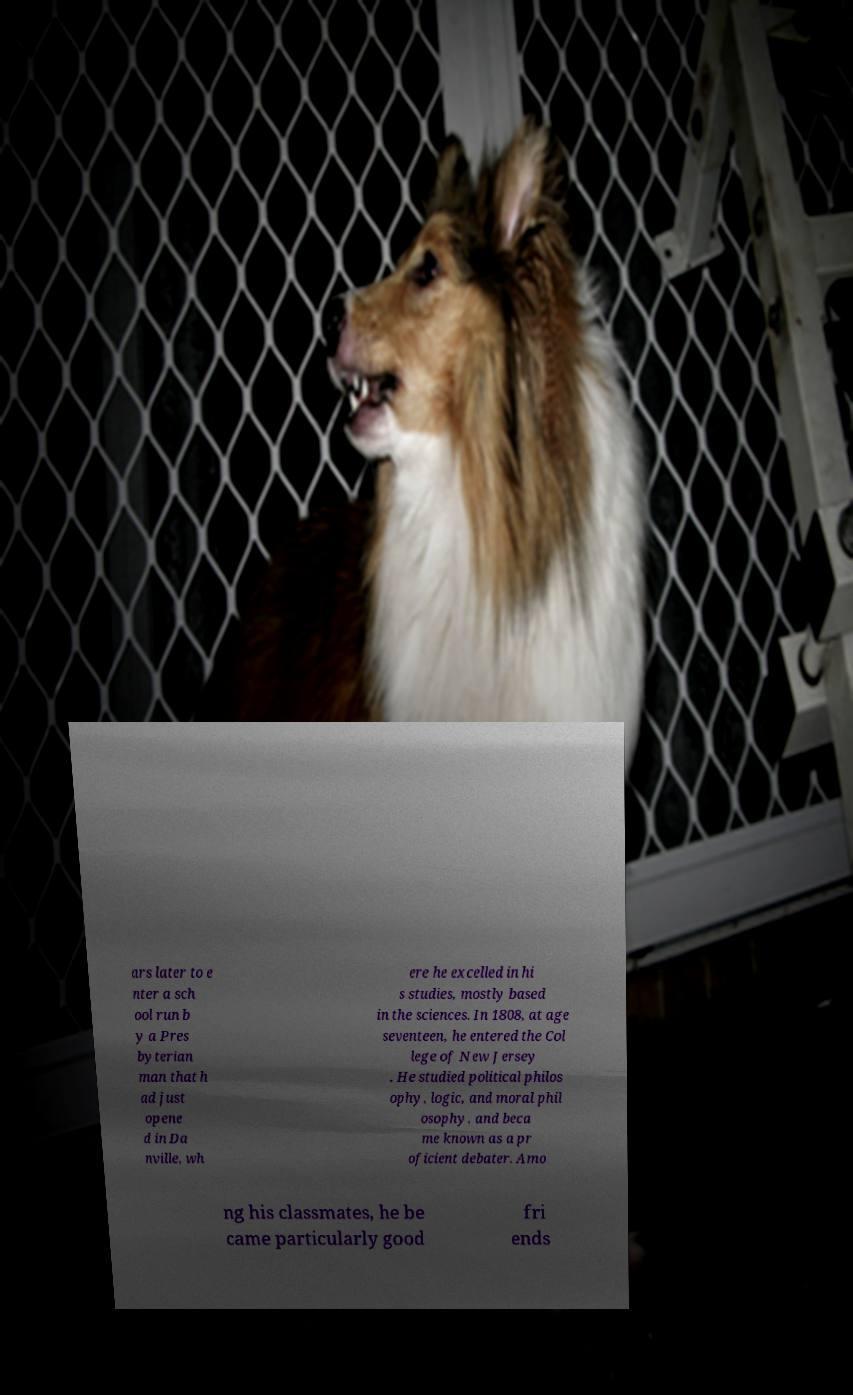Please identify and transcribe the text found in this image. ars later to e nter a sch ool run b y a Pres byterian man that h ad just opene d in Da nville, wh ere he excelled in hi s studies, mostly based in the sciences. In 1808, at age seventeen, he entered the Col lege of New Jersey . He studied political philos ophy, logic, and moral phil osophy, and beca me known as a pr oficient debater. Amo ng his classmates, he be came particularly good fri ends 